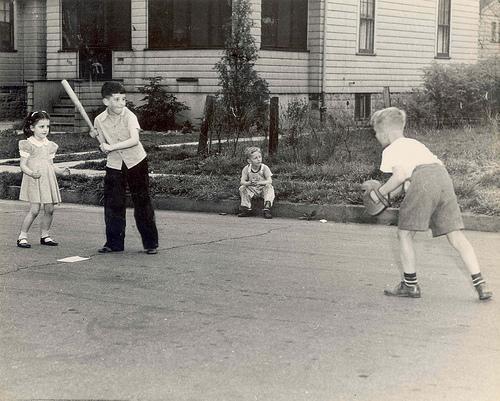How many children are standing in the image?
Give a very brief answer. 3. How many people are playing baseball?
Give a very brief answer. 3. How many childrens have bat in their hand?
Give a very brief answer. 1. How many children are wearing a baseball glove?
Give a very brief answer. 1. 